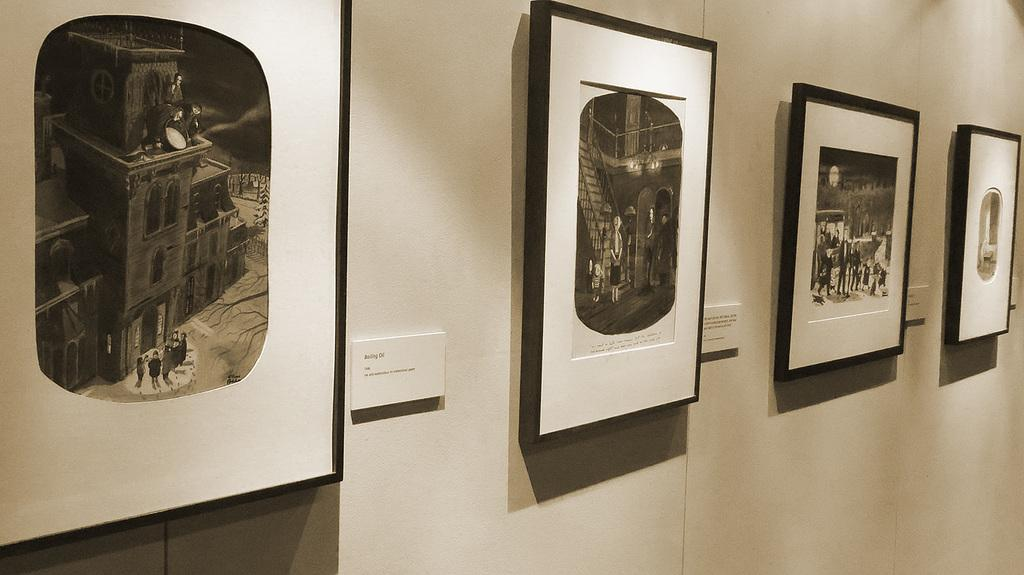What type of artwork is visible in the image? There are portraits in the image. Where are the portraits located? The portraits are placed on a wall. What type of stove is used to cook the nation's favorite dish in the image? There is no stove or mention of cooking or a nation's favorite dish in the image; it only features portraits on a wall. 